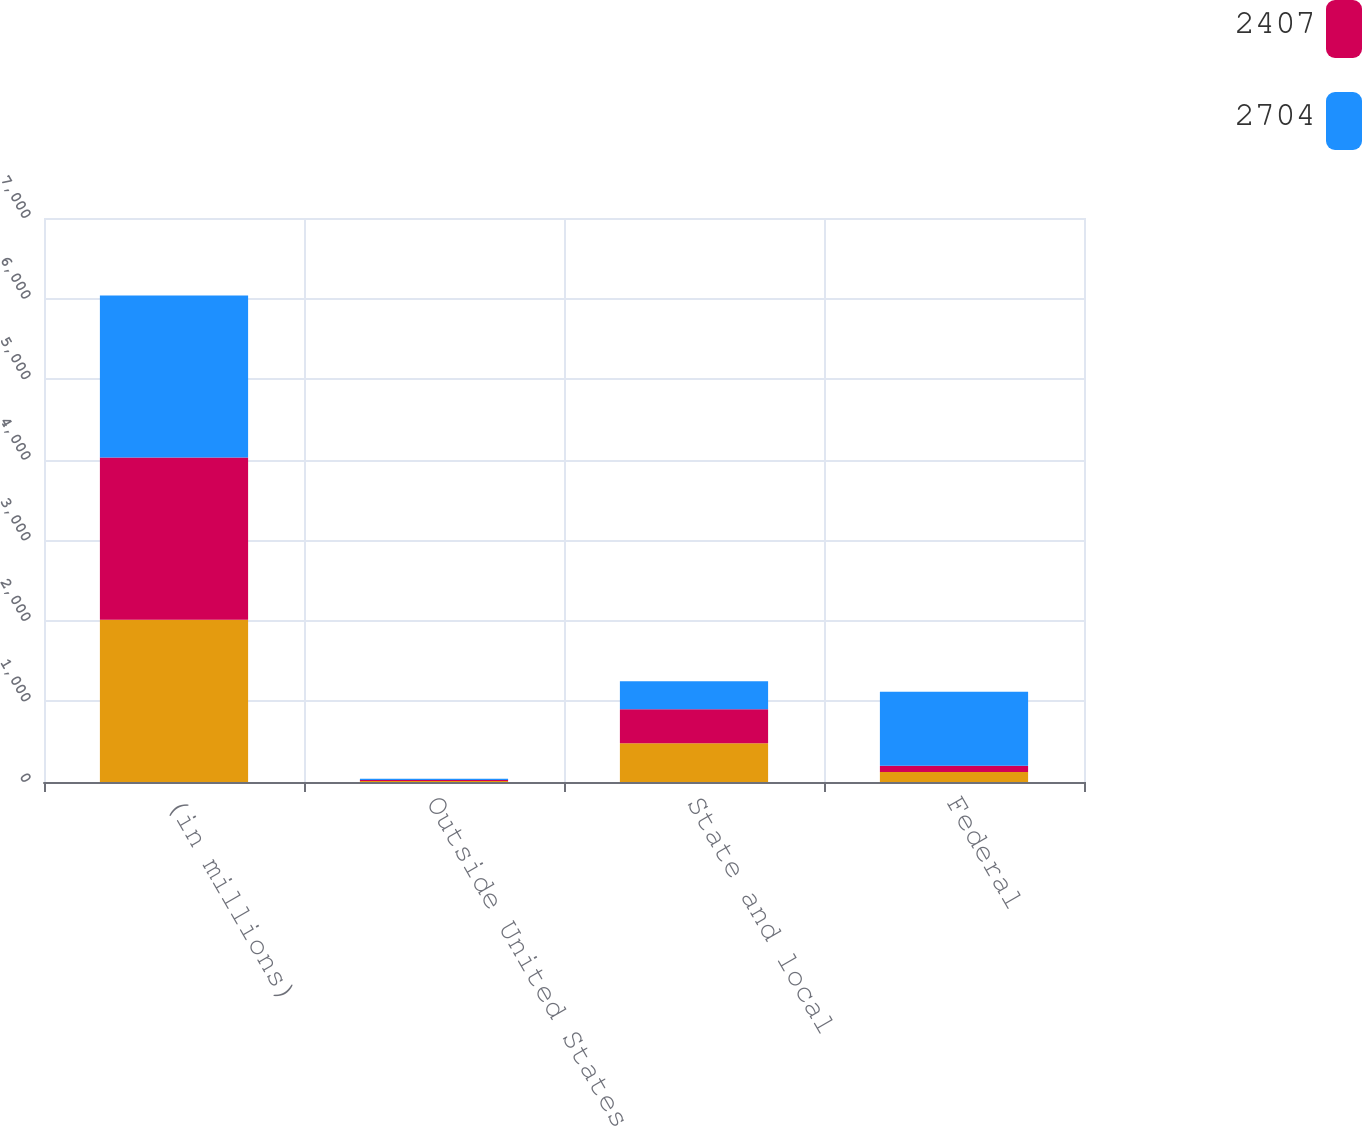<chart> <loc_0><loc_0><loc_500><loc_500><stacked_bar_chart><ecel><fcel>(in millions)<fcel>Outside United States<fcel>State and local<fcel>Federal<nl><fcel>nan<fcel>2014<fcel>11<fcel>480<fcel>124<nl><fcel>2407<fcel>2013<fcel>13<fcel>423<fcel>77<nl><fcel>2704<fcel>2012<fcel>16<fcel>348<fcel>920<nl></chart> 